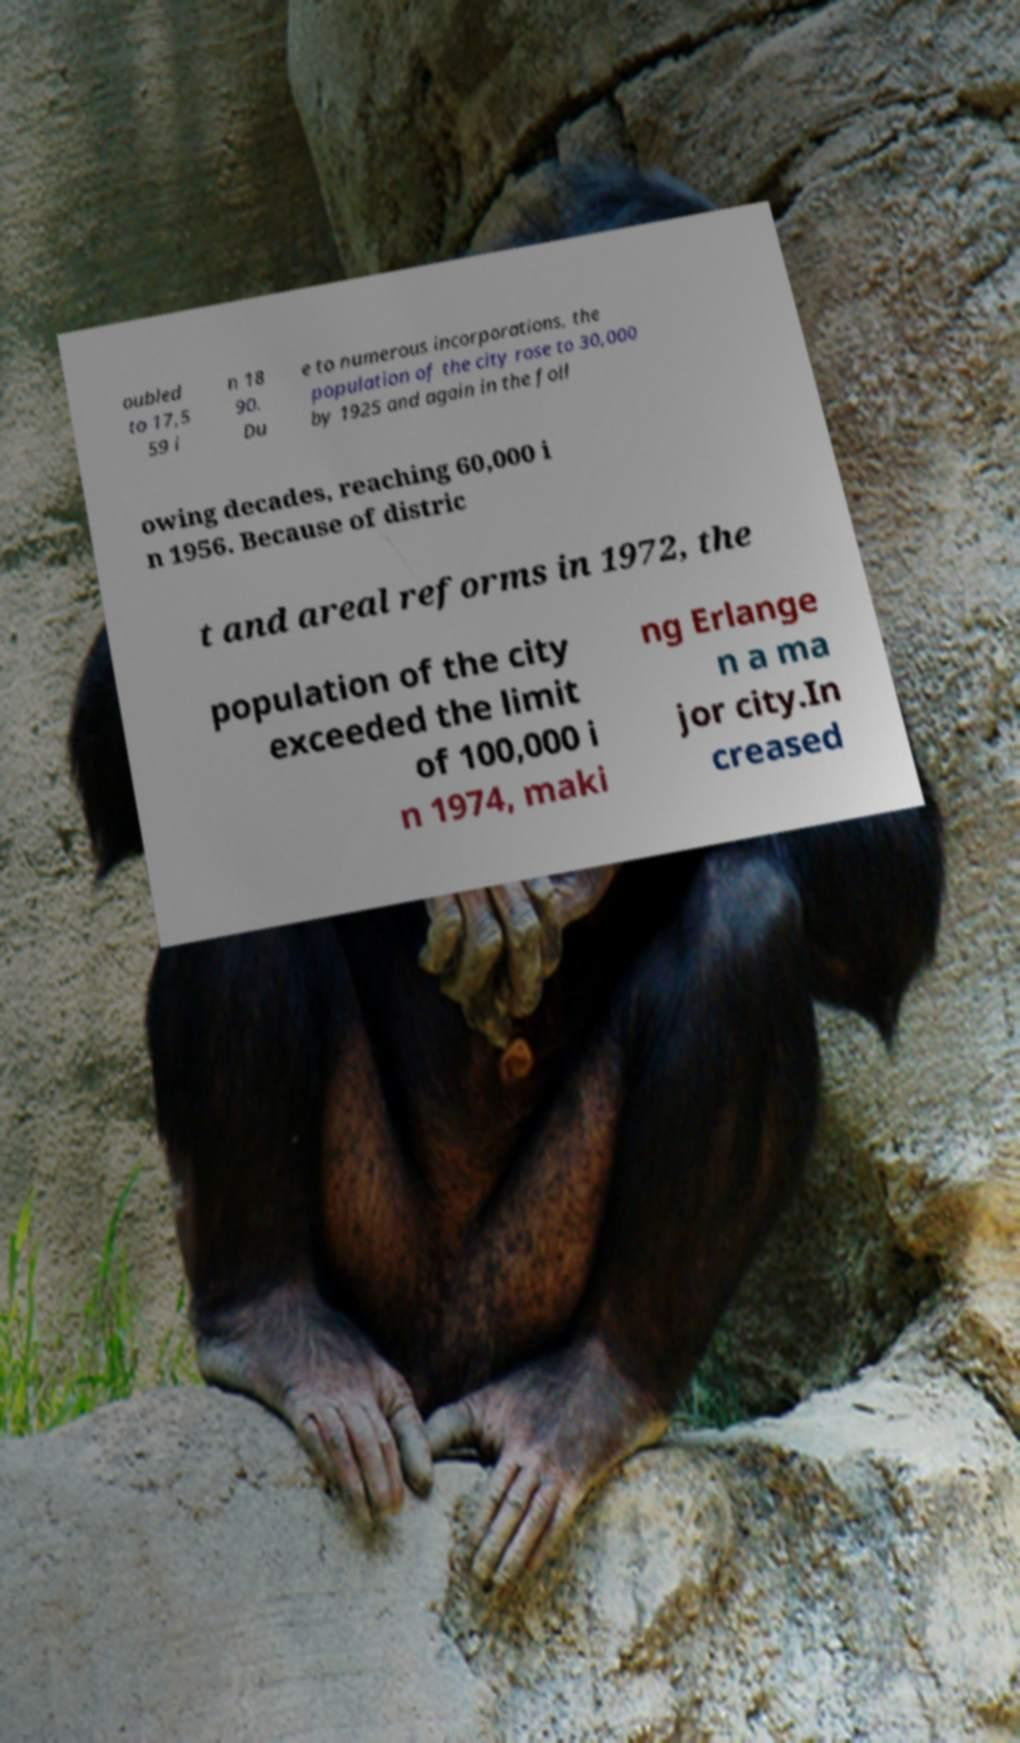Can you read and provide the text displayed in the image?This photo seems to have some interesting text. Can you extract and type it out for me? oubled to 17,5 59 i n 18 90. Du e to numerous incorporations, the population of the city rose to 30,000 by 1925 and again in the foll owing decades, reaching 60,000 i n 1956. Because of distric t and areal reforms in 1972, the population of the city exceeded the limit of 100,000 i n 1974, maki ng Erlange n a ma jor city.In creased 